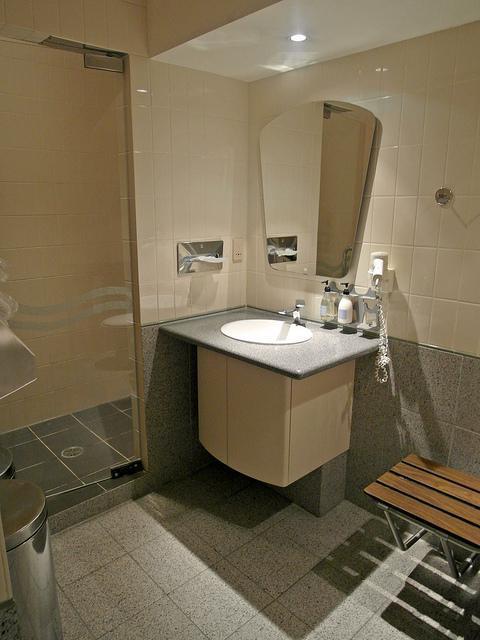What usually happens in this room?
Choose the correct response, then elucidate: 'Answer: answer
Rationale: rationale.'
Options: Pool playing, sleeping, hand washing, cooking. Answer: hand washing.
Rationale: This room contains a sink, soap and towels so, extrapolating from that, it's clear that at least one of the activities that (hopefully) takes place here is hand washing. 